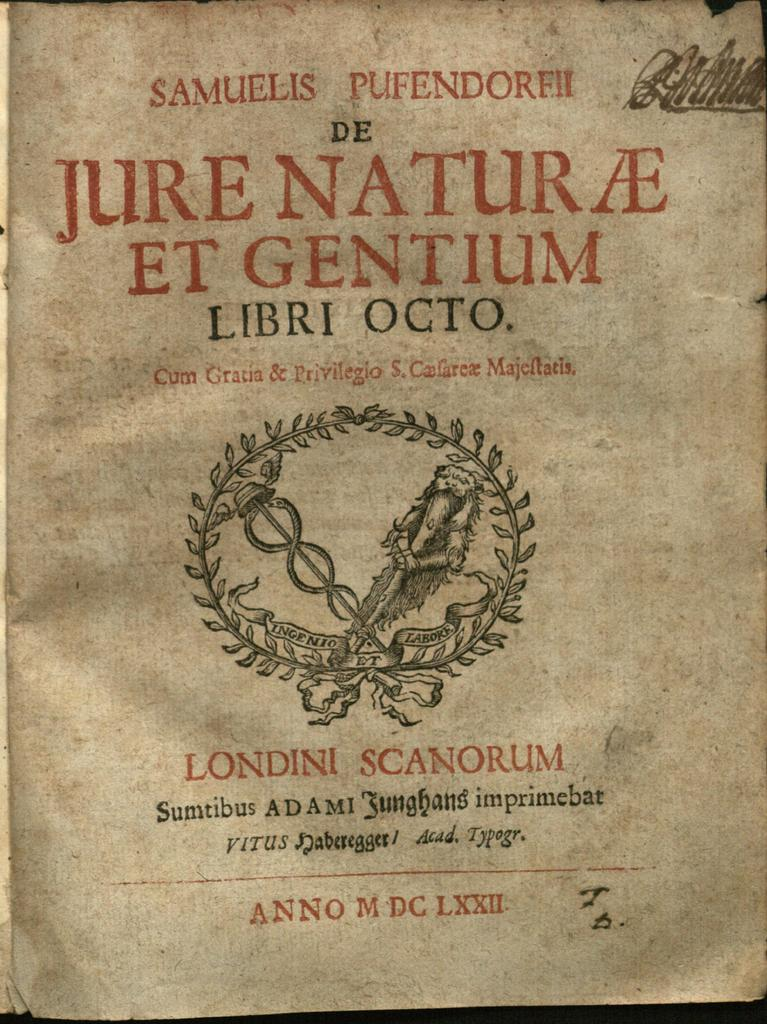<image>
Create a compact narrative representing the image presented. The title page of a book includes the words Londini Scanorum on it. 